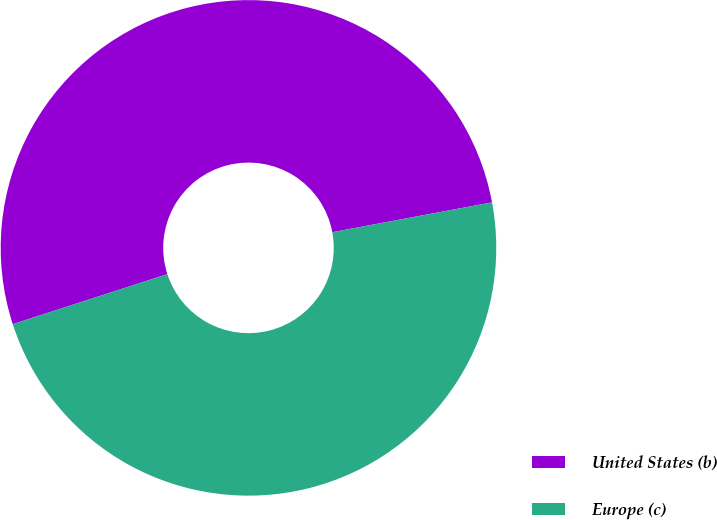<chart> <loc_0><loc_0><loc_500><loc_500><pie_chart><fcel>United States (b)<fcel>Europe (c)<nl><fcel>52.04%<fcel>47.96%<nl></chart> 